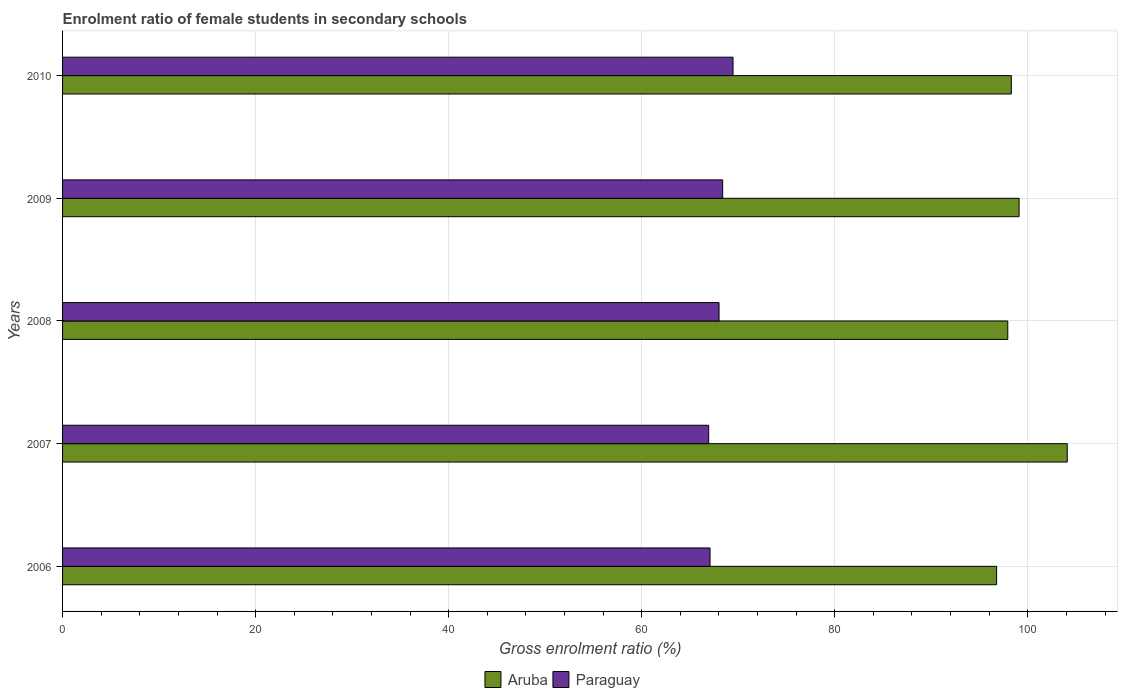How many groups of bars are there?
Make the answer very short. 5. Are the number of bars on each tick of the Y-axis equal?
Ensure brevity in your answer.  Yes. How many bars are there on the 2nd tick from the top?
Make the answer very short. 2. How many bars are there on the 2nd tick from the bottom?
Provide a short and direct response. 2. What is the enrolment ratio of female students in secondary schools in Aruba in 2007?
Ensure brevity in your answer.  104.09. Across all years, what is the maximum enrolment ratio of female students in secondary schools in Paraguay?
Ensure brevity in your answer.  69.46. Across all years, what is the minimum enrolment ratio of female students in secondary schools in Aruba?
Provide a succinct answer. 96.77. In which year was the enrolment ratio of female students in secondary schools in Paraguay maximum?
Your response must be concise. 2010. In which year was the enrolment ratio of female students in secondary schools in Paraguay minimum?
Keep it short and to the point. 2007. What is the total enrolment ratio of female students in secondary schools in Paraguay in the graph?
Your answer should be very brief. 339.89. What is the difference between the enrolment ratio of female students in secondary schools in Paraguay in 2007 and that in 2009?
Your response must be concise. -1.45. What is the difference between the enrolment ratio of female students in secondary schools in Paraguay in 2006 and the enrolment ratio of female students in secondary schools in Aruba in 2007?
Your answer should be very brief. -37.01. What is the average enrolment ratio of female students in secondary schools in Aruba per year?
Keep it short and to the point. 99.24. In the year 2007, what is the difference between the enrolment ratio of female students in secondary schools in Aruba and enrolment ratio of female students in secondary schools in Paraguay?
Your answer should be very brief. 37.15. What is the ratio of the enrolment ratio of female students in secondary schools in Paraguay in 2008 to that in 2010?
Your answer should be very brief. 0.98. Is the difference between the enrolment ratio of female students in secondary schools in Aruba in 2006 and 2008 greater than the difference between the enrolment ratio of female students in secondary schools in Paraguay in 2006 and 2008?
Your answer should be very brief. No. What is the difference between the highest and the second highest enrolment ratio of female students in secondary schools in Paraguay?
Offer a very short reply. 1.07. What is the difference between the highest and the lowest enrolment ratio of female students in secondary schools in Paraguay?
Ensure brevity in your answer.  2.52. Is the sum of the enrolment ratio of female students in secondary schools in Paraguay in 2007 and 2008 greater than the maximum enrolment ratio of female students in secondary schools in Aruba across all years?
Offer a very short reply. Yes. What does the 2nd bar from the top in 2007 represents?
Ensure brevity in your answer.  Aruba. What does the 1st bar from the bottom in 2007 represents?
Make the answer very short. Aruba. How many bars are there?
Your answer should be very brief. 10. Are the values on the major ticks of X-axis written in scientific E-notation?
Offer a very short reply. No. Where does the legend appear in the graph?
Offer a terse response. Bottom center. What is the title of the graph?
Offer a terse response. Enrolment ratio of female students in secondary schools. Does "Pacific island small states" appear as one of the legend labels in the graph?
Your response must be concise. No. What is the label or title of the X-axis?
Provide a succinct answer. Gross enrolment ratio (%). What is the Gross enrolment ratio (%) in Aruba in 2006?
Your answer should be compact. 96.77. What is the Gross enrolment ratio (%) in Paraguay in 2006?
Your answer should be very brief. 67.08. What is the Gross enrolment ratio (%) of Aruba in 2007?
Give a very brief answer. 104.09. What is the Gross enrolment ratio (%) of Paraguay in 2007?
Give a very brief answer. 66.94. What is the Gross enrolment ratio (%) of Aruba in 2008?
Your answer should be very brief. 97.93. What is the Gross enrolment ratio (%) of Paraguay in 2008?
Keep it short and to the point. 68.01. What is the Gross enrolment ratio (%) in Aruba in 2009?
Offer a very short reply. 99.1. What is the Gross enrolment ratio (%) of Paraguay in 2009?
Make the answer very short. 68.39. What is the Gross enrolment ratio (%) in Aruba in 2010?
Offer a terse response. 98.29. What is the Gross enrolment ratio (%) of Paraguay in 2010?
Provide a short and direct response. 69.46. Across all years, what is the maximum Gross enrolment ratio (%) in Aruba?
Provide a short and direct response. 104.09. Across all years, what is the maximum Gross enrolment ratio (%) of Paraguay?
Ensure brevity in your answer.  69.46. Across all years, what is the minimum Gross enrolment ratio (%) of Aruba?
Your answer should be compact. 96.77. Across all years, what is the minimum Gross enrolment ratio (%) of Paraguay?
Offer a terse response. 66.94. What is the total Gross enrolment ratio (%) of Aruba in the graph?
Your answer should be very brief. 496.19. What is the total Gross enrolment ratio (%) of Paraguay in the graph?
Your answer should be very brief. 339.89. What is the difference between the Gross enrolment ratio (%) in Aruba in 2006 and that in 2007?
Keep it short and to the point. -7.32. What is the difference between the Gross enrolment ratio (%) in Paraguay in 2006 and that in 2007?
Offer a very short reply. 0.14. What is the difference between the Gross enrolment ratio (%) in Aruba in 2006 and that in 2008?
Make the answer very short. -1.16. What is the difference between the Gross enrolment ratio (%) in Paraguay in 2006 and that in 2008?
Give a very brief answer. -0.93. What is the difference between the Gross enrolment ratio (%) of Aruba in 2006 and that in 2009?
Your answer should be very brief. -2.33. What is the difference between the Gross enrolment ratio (%) in Paraguay in 2006 and that in 2009?
Provide a short and direct response. -1.31. What is the difference between the Gross enrolment ratio (%) in Aruba in 2006 and that in 2010?
Provide a short and direct response. -1.52. What is the difference between the Gross enrolment ratio (%) of Paraguay in 2006 and that in 2010?
Your answer should be very brief. -2.38. What is the difference between the Gross enrolment ratio (%) in Aruba in 2007 and that in 2008?
Give a very brief answer. 6.16. What is the difference between the Gross enrolment ratio (%) in Paraguay in 2007 and that in 2008?
Offer a very short reply. -1.07. What is the difference between the Gross enrolment ratio (%) of Aruba in 2007 and that in 2009?
Your response must be concise. 4.99. What is the difference between the Gross enrolment ratio (%) of Paraguay in 2007 and that in 2009?
Ensure brevity in your answer.  -1.45. What is the difference between the Gross enrolment ratio (%) in Aruba in 2007 and that in 2010?
Your answer should be very brief. 5.8. What is the difference between the Gross enrolment ratio (%) in Paraguay in 2007 and that in 2010?
Provide a short and direct response. -2.52. What is the difference between the Gross enrolment ratio (%) in Aruba in 2008 and that in 2009?
Your answer should be very brief. -1.17. What is the difference between the Gross enrolment ratio (%) in Paraguay in 2008 and that in 2009?
Offer a terse response. -0.38. What is the difference between the Gross enrolment ratio (%) in Aruba in 2008 and that in 2010?
Provide a succinct answer. -0.37. What is the difference between the Gross enrolment ratio (%) of Paraguay in 2008 and that in 2010?
Offer a terse response. -1.45. What is the difference between the Gross enrolment ratio (%) in Aruba in 2009 and that in 2010?
Make the answer very short. 0.81. What is the difference between the Gross enrolment ratio (%) of Paraguay in 2009 and that in 2010?
Make the answer very short. -1.07. What is the difference between the Gross enrolment ratio (%) in Aruba in 2006 and the Gross enrolment ratio (%) in Paraguay in 2007?
Your answer should be compact. 29.83. What is the difference between the Gross enrolment ratio (%) in Aruba in 2006 and the Gross enrolment ratio (%) in Paraguay in 2008?
Your response must be concise. 28.76. What is the difference between the Gross enrolment ratio (%) in Aruba in 2006 and the Gross enrolment ratio (%) in Paraguay in 2009?
Make the answer very short. 28.38. What is the difference between the Gross enrolment ratio (%) of Aruba in 2006 and the Gross enrolment ratio (%) of Paraguay in 2010?
Your answer should be very brief. 27.31. What is the difference between the Gross enrolment ratio (%) of Aruba in 2007 and the Gross enrolment ratio (%) of Paraguay in 2008?
Your answer should be compact. 36.08. What is the difference between the Gross enrolment ratio (%) in Aruba in 2007 and the Gross enrolment ratio (%) in Paraguay in 2009?
Your answer should be compact. 35.7. What is the difference between the Gross enrolment ratio (%) of Aruba in 2007 and the Gross enrolment ratio (%) of Paraguay in 2010?
Keep it short and to the point. 34.63. What is the difference between the Gross enrolment ratio (%) of Aruba in 2008 and the Gross enrolment ratio (%) of Paraguay in 2009?
Keep it short and to the point. 29.54. What is the difference between the Gross enrolment ratio (%) in Aruba in 2008 and the Gross enrolment ratio (%) in Paraguay in 2010?
Offer a very short reply. 28.46. What is the difference between the Gross enrolment ratio (%) in Aruba in 2009 and the Gross enrolment ratio (%) in Paraguay in 2010?
Ensure brevity in your answer.  29.64. What is the average Gross enrolment ratio (%) of Aruba per year?
Provide a short and direct response. 99.24. What is the average Gross enrolment ratio (%) in Paraguay per year?
Make the answer very short. 67.98. In the year 2006, what is the difference between the Gross enrolment ratio (%) of Aruba and Gross enrolment ratio (%) of Paraguay?
Make the answer very short. 29.69. In the year 2007, what is the difference between the Gross enrolment ratio (%) of Aruba and Gross enrolment ratio (%) of Paraguay?
Offer a terse response. 37.15. In the year 2008, what is the difference between the Gross enrolment ratio (%) of Aruba and Gross enrolment ratio (%) of Paraguay?
Provide a short and direct response. 29.91. In the year 2009, what is the difference between the Gross enrolment ratio (%) of Aruba and Gross enrolment ratio (%) of Paraguay?
Ensure brevity in your answer.  30.71. In the year 2010, what is the difference between the Gross enrolment ratio (%) of Aruba and Gross enrolment ratio (%) of Paraguay?
Make the answer very short. 28.83. What is the ratio of the Gross enrolment ratio (%) in Aruba in 2006 to that in 2007?
Your response must be concise. 0.93. What is the ratio of the Gross enrolment ratio (%) in Paraguay in 2006 to that in 2008?
Make the answer very short. 0.99. What is the ratio of the Gross enrolment ratio (%) in Aruba in 2006 to that in 2009?
Keep it short and to the point. 0.98. What is the ratio of the Gross enrolment ratio (%) in Paraguay in 2006 to that in 2009?
Ensure brevity in your answer.  0.98. What is the ratio of the Gross enrolment ratio (%) in Aruba in 2006 to that in 2010?
Make the answer very short. 0.98. What is the ratio of the Gross enrolment ratio (%) of Paraguay in 2006 to that in 2010?
Offer a terse response. 0.97. What is the ratio of the Gross enrolment ratio (%) in Aruba in 2007 to that in 2008?
Your answer should be compact. 1.06. What is the ratio of the Gross enrolment ratio (%) of Paraguay in 2007 to that in 2008?
Provide a succinct answer. 0.98. What is the ratio of the Gross enrolment ratio (%) in Aruba in 2007 to that in 2009?
Make the answer very short. 1.05. What is the ratio of the Gross enrolment ratio (%) in Paraguay in 2007 to that in 2009?
Provide a short and direct response. 0.98. What is the ratio of the Gross enrolment ratio (%) of Aruba in 2007 to that in 2010?
Offer a very short reply. 1.06. What is the ratio of the Gross enrolment ratio (%) of Paraguay in 2007 to that in 2010?
Your response must be concise. 0.96. What is the ratio of the Gross enrolment ratio (%) of Aruba in 2008 to that in 2009?
Make the answer very short. 0.99. What is the ratio of the Gross enrolment ratio (%) in Paraguay in 2008 to that in 2009?
Give a very brief answer. 0.99. What is the ratio of the Gross enrolment ratio (%) in Paraguay in 2008 to that in 2010?
Keep it short and to the point. 0.98. What is the ratio of the Gross enrolment ratio (%) of Aruba in 2009 to that in 2010?
Your answer should be very brief. 1.01. What is the ratio of the Gross enrolment ratio (%) in Paraguay in 2009 to that in 2010?
Keep it short and to the point. 0.98. What is the difference between the highest and the second highest Gross enrolment ratio (%) in Aruba?
Give a very brief answer. 4.99. What is the difference between the highest and the second highest Gross enrolment ratio (%) of Paraguay?
Your answer should be very brief. 1.07. What is the difference between the highest and the lowest Gross enrolment ratio (%) in Aruba?
Offer a very short reply. 7.32. What is the difference between the highest and the lowest Gross enrolment ratio (%) in Paraguay?
Your response must be concise. 2.52. 